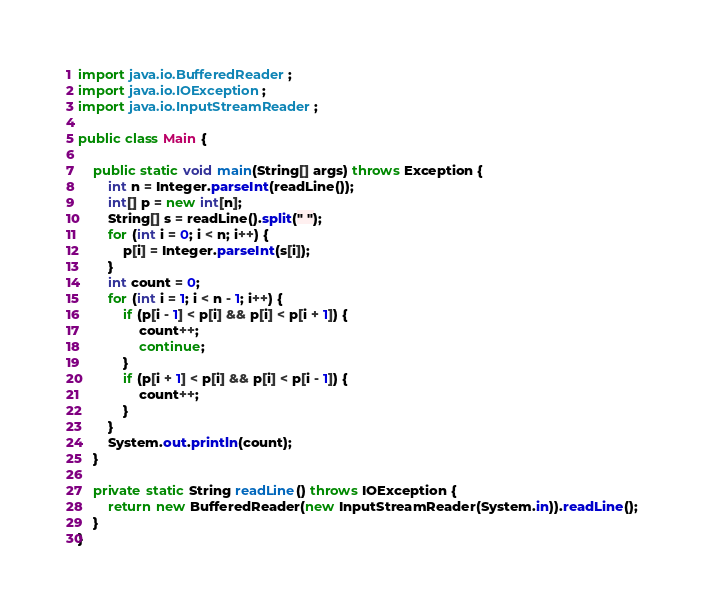Convert code to text. <code><loc_0><loc_0><loc_500><loc_500><_Java_>
import java.io.BufferedReader;
import java.io.IOException;
import java.io.InputStreamReader;

public class Main {

	public static void main(String[] args) throws Exception {
		int n = Integer.parseInt(readLine());
		int[] p = new int[n];
		String[] s = readLine().split(" ");
		for (int i = 0; i < n; i++) {
			p[i] = Integer.parseInt(s[i]);
		}
		int count = 0;
		for (int i = 1; i < n - 1; i++) {
			if (p[i - 1] < p[i] && p[i] < p[i + 1]) {
				count++;
				continue;
			}
			if (p[i + 1] < p[i] && p[i] < p[i - 1]) {
				count++;
			}
		}
		System.out.println(count);
	}
	
	private static String readLine() throws IOException {
		return new BufferedReader(new InputStreamReader(System.in)).readLine();
	}
}
</code> 